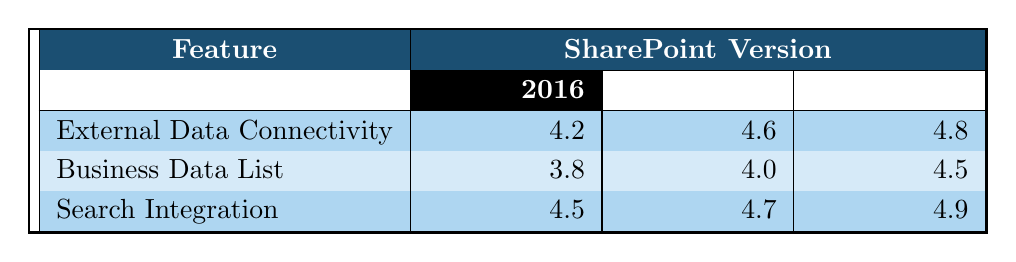What is the user feedback score for Search Integration in the Subscription Edition? Looking at the table, the score for Search Integration under the Subscription Edition is listed as 4.9.
Answer: 4.9 Which SharePoint version has the highest score for External Data Connectivity? The table shows the scores for External Data Connectivity as follows: 4.2 for 2016, 4.6 for 2019, and 4.8 for Subscription Edition. The highest score is 4.8 for the Subscription Edition.
Answer: Subscription Edition What is the average user feedback score for Business Data List across all SharePoint versions? The scores for Business Data List are 3.8 for 2016, 4.0 for 2019, and 4.5 for Subscription Edition. The average is calculated by summing these scores (3.8 + 4.0 + 4.5 = 12.3) and dividing by 3, which gives 12.3 / 3 = 4.1.
Answer: 4.1 Did the score for Search Integration improve from SharePoint 2016 to 2019? The score for Search Integration is 4.5 in 2016 and 4.7 in 2019. Since 4.7 is greater than 4.5, this indicates an improvement.
Answer: Yes What was the difference in user feedback scores for External Data Connectivity between 2019 and Subscription Edition? The score for External Data Connectivity in 2019 is 4.6 and in Subscription Edition it is 4.8. The difference is calculated as 4.8 - 4.6 = 0.2.
Answer: 0.2 Which feature received the lowest feedback score in SharePoint 2016? The feature scores in SharePoint 2016 are 4.2 for External Data Connectivity, 3.8 for Business Data List, and 4.5 for Search Integration. The lowest score is 3.8 for Business Data List.
Answer: Business Data List How did the overall trend in feedback scores for Search Integration progress from 2016 to Subscription Edition? The scores for Search Integration are 4.5 in 2016, 4.7 in 2019, and 4.9 in Subscription Edition. We observe a consistent increase in scores: from 4.5 to 4.7 (an increase of 0.2) and from 4.7 to 4.9 (another increase of 0.2).
Answer: Continuous increase Is the score for Business Data List in Subscription Edition higher than in 2016? The score for Business Data List in Subscription Edition is 4.5 while in 2016, it is 3.8. Since 4.5 is greater than 3.8, the score is indeed higher.
Answer: Yes 